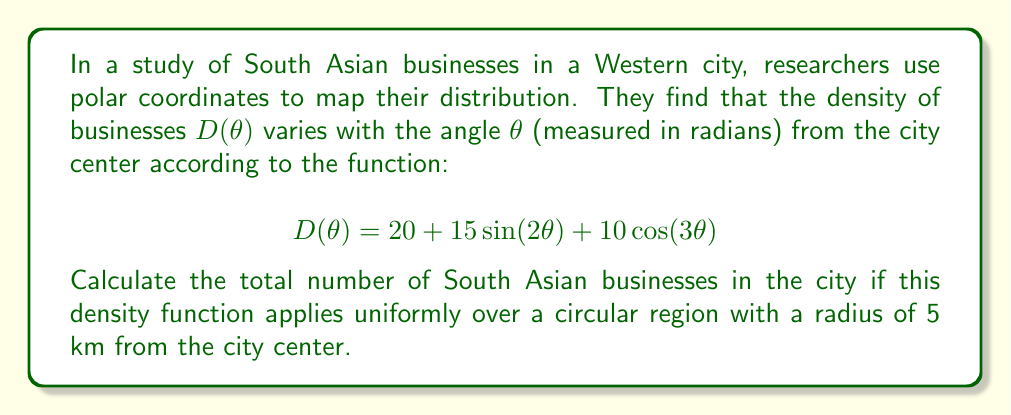Teach me how to tackle this problem. To solve this problem, we need to integrate the density function over the entire circular region. In polar coordinates, this involves a double integral:

1) The total number of businesses $N$ is given by:

   $$N = \int_0^{2\pi} \int_0^5 rD(\theta) \, dr \, d\theta$$

2) Substituting the given density function:

   $$N = \int_0^{2\pi} \int_0^5 r(20 + 15\sin(2\theta) + 10\cos(3\theta)) \, dr \, d\theta$$

3) First, integrate with respect to $r$:

   $$N = \int_0^{2\pi} \left[\frac{r^2}{2}(20 + 15\sin(2\theta) + 10\cos(3\theta))\right]_0^5 \, d\theta$$

   $$N = \int_0^{2\pi} \frac{25}{2}(20 + 15\sin(2\theta) + 10\cos(3\theta)) \, d\theta$$

4) Simplify:

   $$N = 250\int_0^{2\pi} (20 + 15\sin(2\theta) + 10\cos(3\theta)) \, d\theta$$

5) Integrate each term:

   $$N = 250\left[20\theta - \frac{15}{2}\cos(2\theta) + \frac{10}{3}\sin(3\theta)\right]_0^{2\pi}$$

6) Evaluate at the limits:

   $$N = 250\left[(20(2\pi) - \frac{15}{2}(\cos(4\pi) - \cos(0)) + \frac{10}{3}(\sin(6\pi) - \sin(0))\right]$$

7) Simplify, noting that $\cos(4\pi) = 1$, $\cos(0) = 1$, $\sin(6\pi) = 0$, and $\sin(0) = 0$:

   $$N = 250(40\pi) = 10000\pi$$

Therefore, the total number of South Asian businesses in the city is $10000\pi$.
Answer: $10000\pi$ businesses 